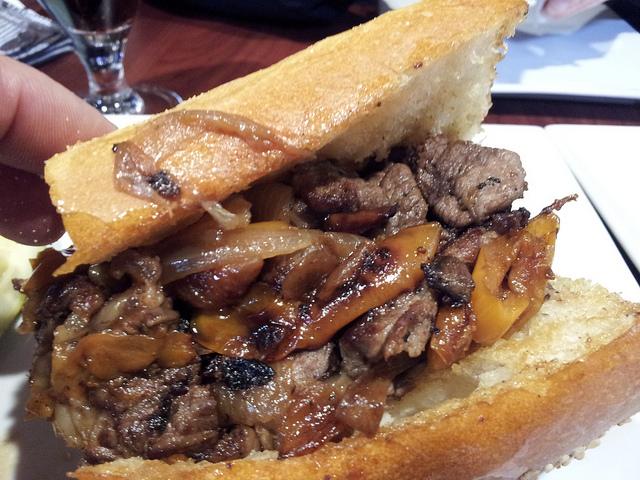Will this sandwich be messy to eat?
Write a very short answer. Yes. What are the ingredients in the sandwich?
Answer briefly. Beef and onions. Is the sandwich on a plate?
Short answer required. No. 